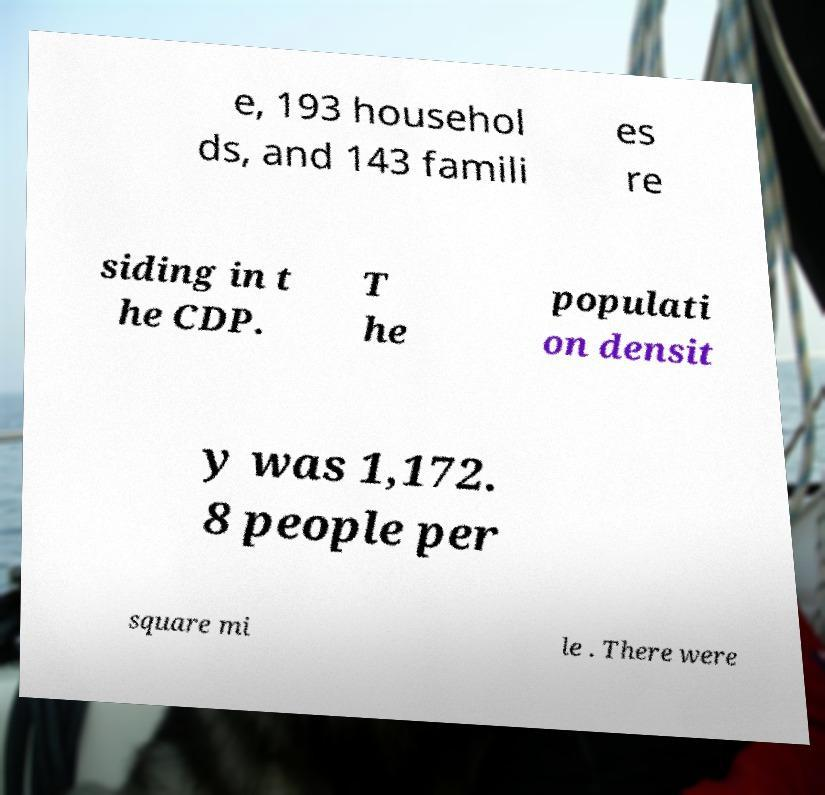Could you extract and type out the text from this image? e, 193 househol ds, and 143 famili es re siding in t he CDP. T he populati on densit y was 1,172. 8 people per square mi le . There were 